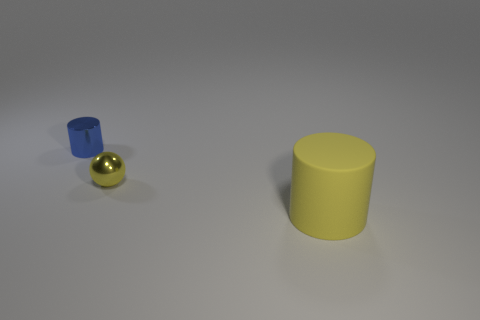Is there any significance to the arrangement of the objects in the image? The arrangement of the objects may suggest an intentional composition for aesthetic or demonstrative purposes, such as a study of color contrast, reflections, and shapes. The cool blue and warm yellow provide a visual juxtaposition, while the shiny sphere adds a dynamic element of reflection to the setup. 